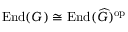Convert formula to latex. <formula><loc_0><loc_0><loc_500><loc_500>{ E n d } ( G ) \cong { E n d } ( { \widehat { G } } ) ^ { o p }</formula> 